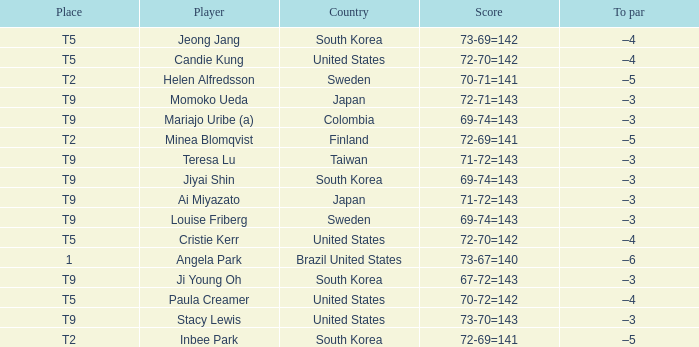Who placed t5 and had a score of 70-72=142? Paula Creamer. 